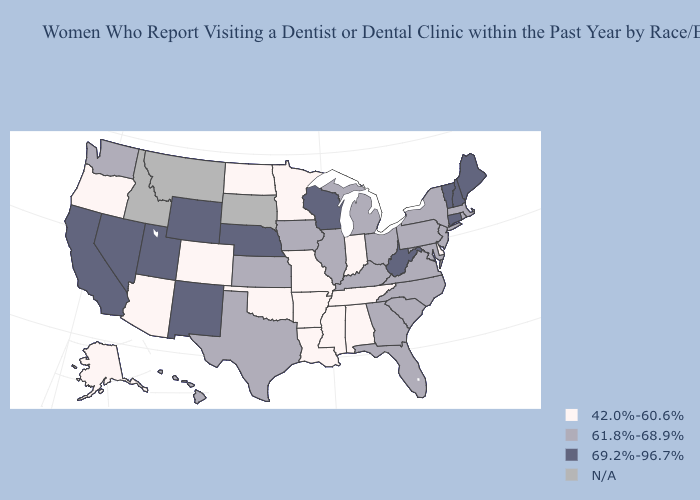Does West Virginia have the highest value in the USA?
Give a very brief answer. Yes. Name the states that have a value in the range N/A?
Give a very brief answer. Idaho, Montana, South Dakota. Does Mississippi have the highest value in the USA?
Keep it brief. No. Does the first symbol in the legend represent the smallest category?
Be succinct. Yes. Among the states that border Washington , which have the highest value?
Short answer required. Oregon. Name the states that have a value in the range N/A?
Quick response, please. Idaho, Montana, South Dakota. What is the highest value in the MidWest ?
Quick response, please. 69.2%-96.7%. Name the states that have a value in the range 61.8%-68.9%?
Short answer required. Florida, Georgia, Hawaii, Illinois, Iowa, Kansas, Kentucky, Maryland, Massachusetts, Michigan, New Jersey, New York, North Carolina, Ohio, Pennsylvania, Rhode Island, South Carolina, Texas, Virginia, Washington. Name the states that have a value in the range 69.2%-96.7%?
Keep it brief. California, Connecticut, Maine, Nebraska, Nevada, New Hampshire, New Mexico, Utah, Vermont, West Virginia, Wisconsin, Wyoming. Name the states that have a value in the range 42.0%-60.6%?
Write a very short answer. Alabama, Alaska, Arizona, Arkansas, Colorado, Delaware, Indiana, Louisiana, Minnesota, Mississippi, Missouri, North Dakota, Oklahoma, Oregon, Tennessee. Name the states that have a value in the range 42.0%-60.6%?
Short answer required. Alabama, Alaska, Arizona, Arkansas, Colorado, Delaware, Indiana, Louisiana, Minnesota, Mississippi, Missouri, North Dakota, Oklahoma, Oregon, Tennessee. Name the states that have a value in the range 42.0%-60.6%?
Keep it brief. Alabama, Alaska, Arizona, Arkansas, Colorado, Delaware, Indiana, Louisiana, Minnesota, Mississippi, Missouri, North Dakota, Oklahoma, Oregon, Tennessee. How many symbols are there in the legend?
Give a very brief answer. 4. What is the lowest value in the West?
Give a very brief answer. 42.0%-60.6%. Name the states that have a value in the range 42.0%-60.6%?
Answer briefly. Alabama, Alaska, Arizona, Arkansas, Colorado, Delaware, Indiana, Louisiana, Minnesota, Mississippi, Missouri, North Dakota, Oklahoma, Oregon, Tennessee. 